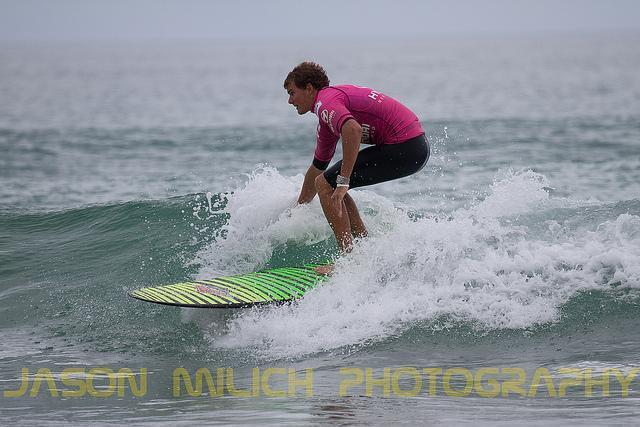How many surfboards can be seen?
Give a very brief answer. 1. 